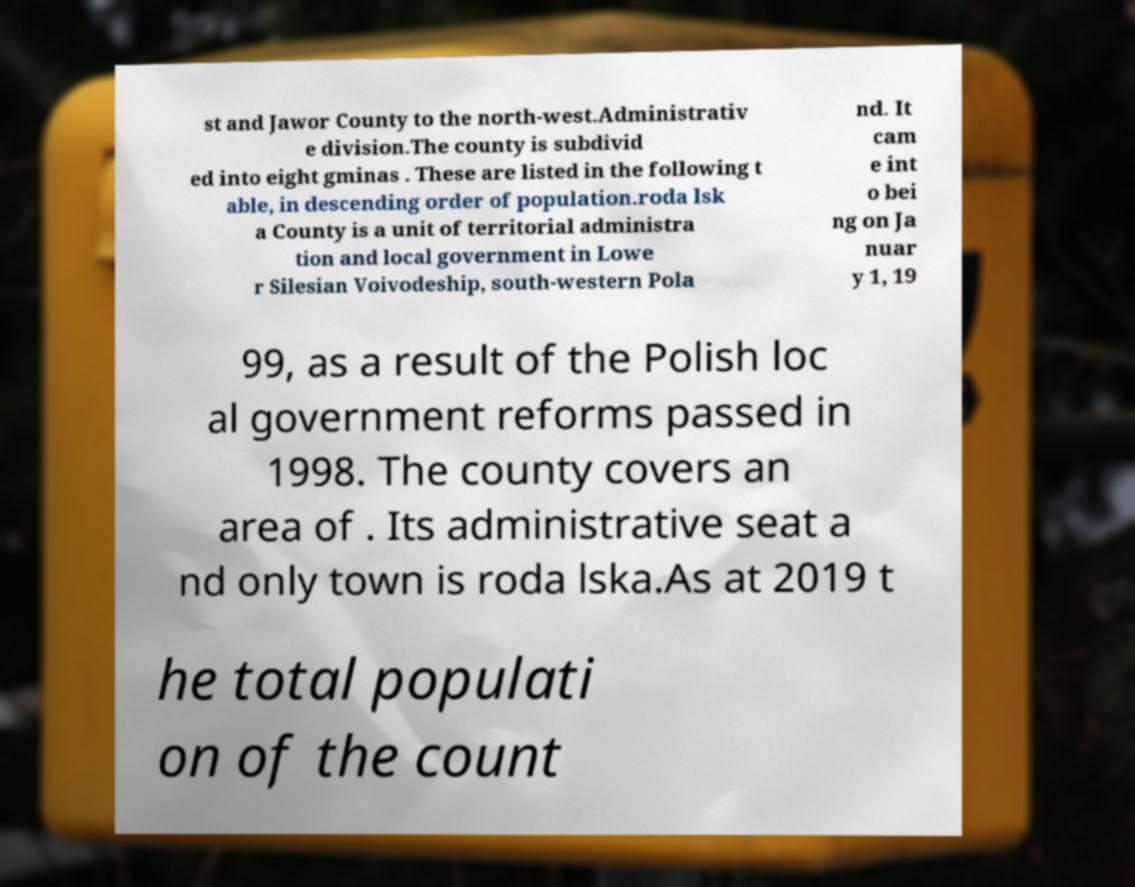Could you assist in decoding the text presented in this image and type it out clearly? st and Jawor County to the north-west.Administrativ e division.The county is subdivid ed into eight gminas . These are listed in the following t able, in descending order of population.roda lsk a County is a unit of territorial administra tion and local government in Lowe r Silesian Voivodeship, south-western Pola nd. It cam e int o bei ng on Ja nuar y 1, 19 99, as a result of the Polish loc al government reforms passed in 1998. The county covers an area of . Its administrative seat a nd only town is roda lska.As at 2019 t he total populati on of the count 